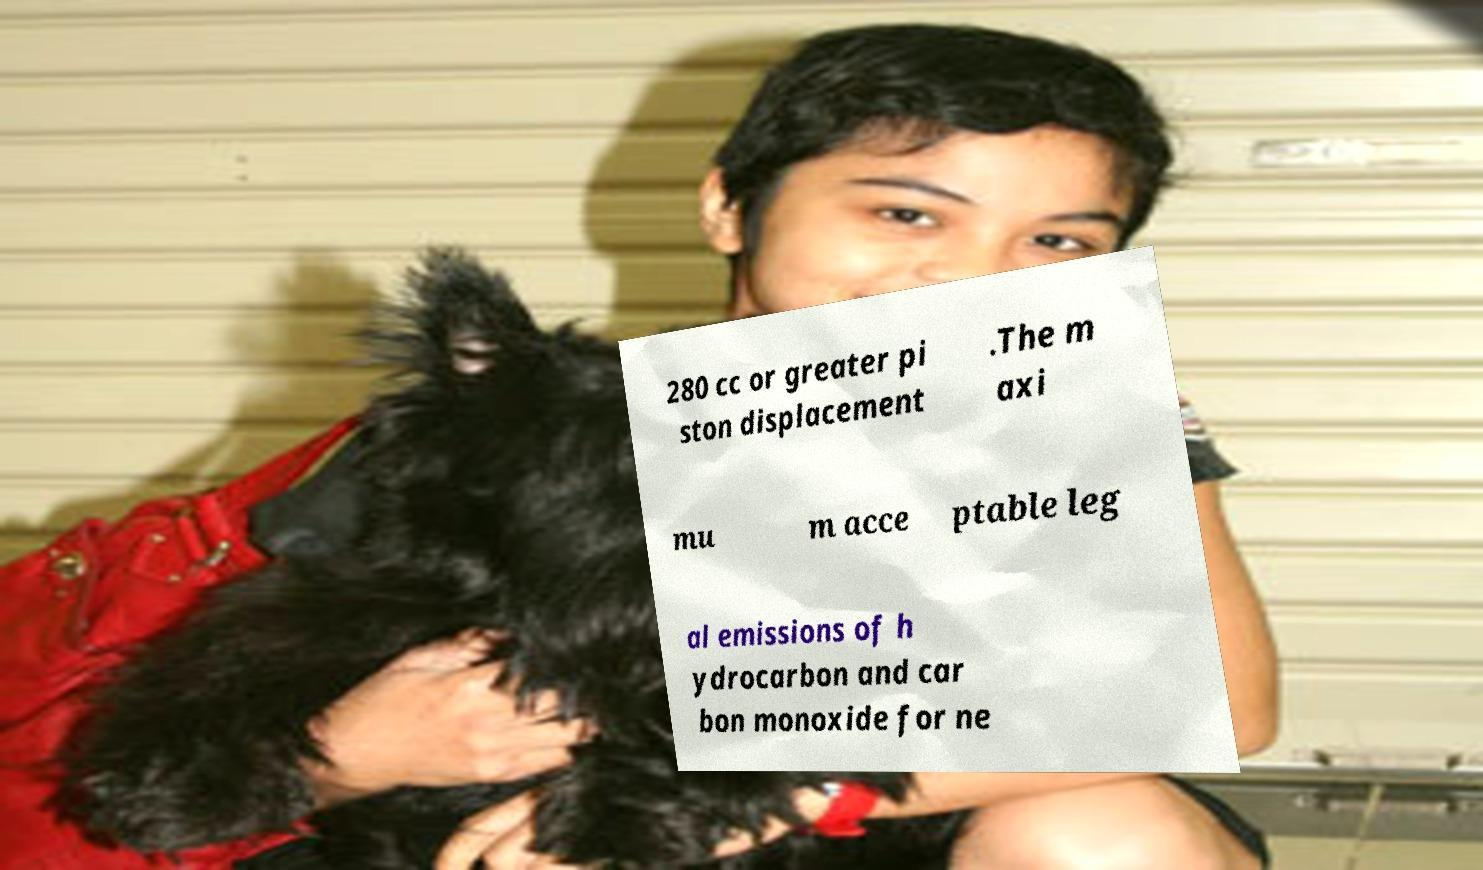For documentation purposes, I need the text within this image transcribed. Could you provide that? 280 cc or greater pi ston displacement .The m axi mu m acce ptable leg al emissions of h ydrocarbon and car bon monoxide for ne 